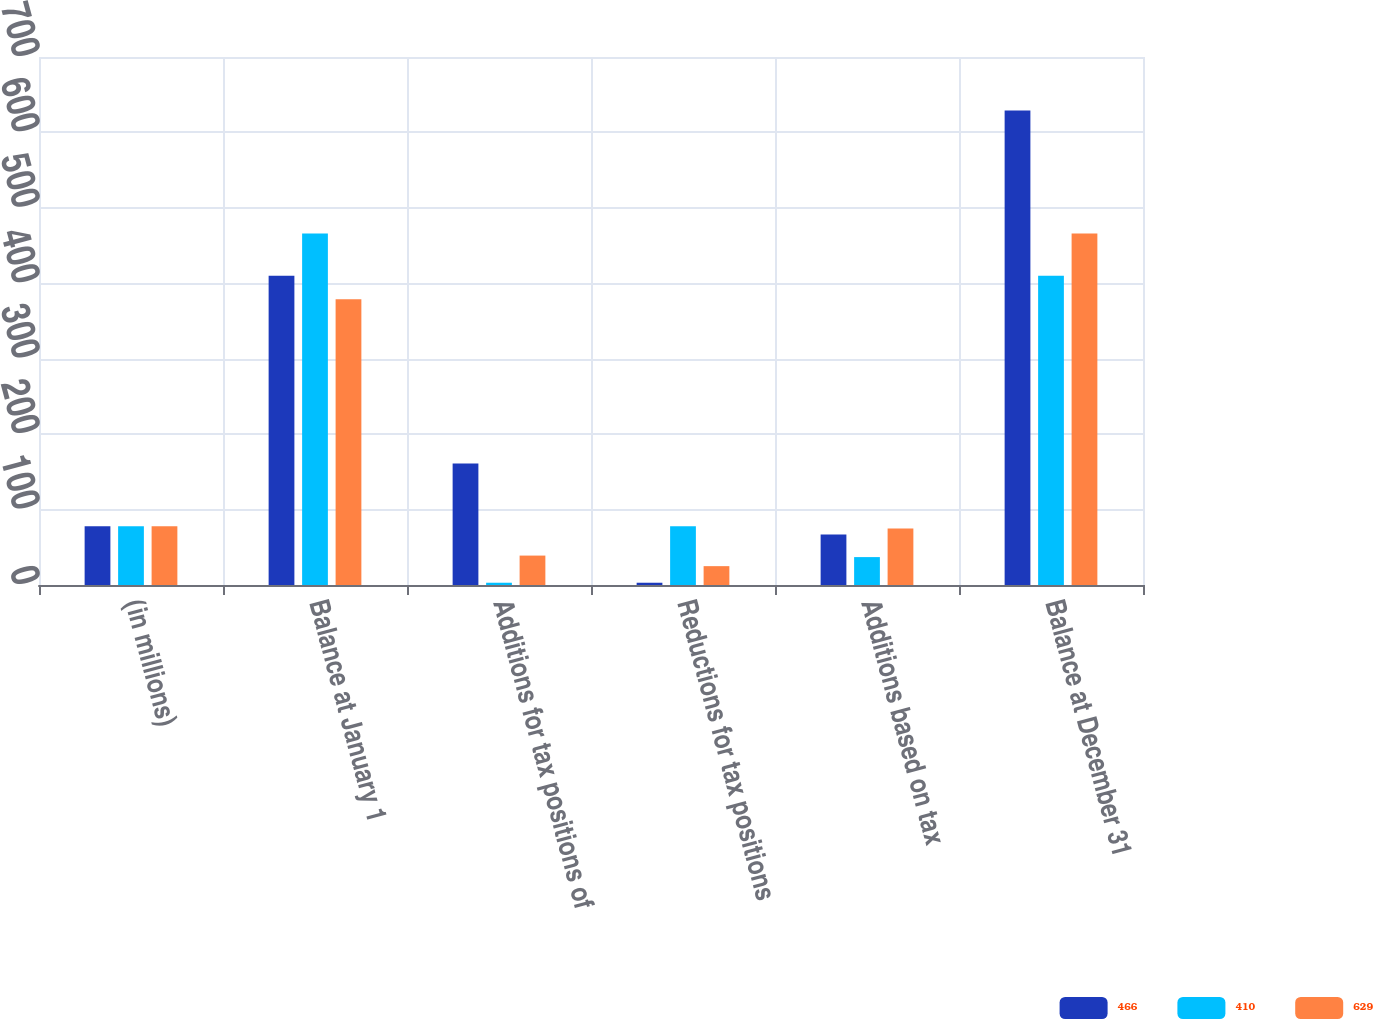Convert chart to OTSL. <chart><loc_0><loc_0><loc_500><loc_500><stacked_bar_chart><ecel><fcel>(in millions)<fcel>Balance at January 1<fcel>Additions for tax positions of<fcel>Reductions for tax positions<fcel>Additions based on tax<fcel>Balance at December 31<nl><fcel>466<fcel>78<fcel>410<fcel>161<fcel>3<fcel>67<fcel>629<nl><fcel>410<fcel>78<fcel>466<fcel>3<fcel>78<fcel>37<fcel>410<nl><fcel>629<fcel>78<fcel>379<fcel>39<fcel>25<fcel>75<fcel>466<nl></chart> 